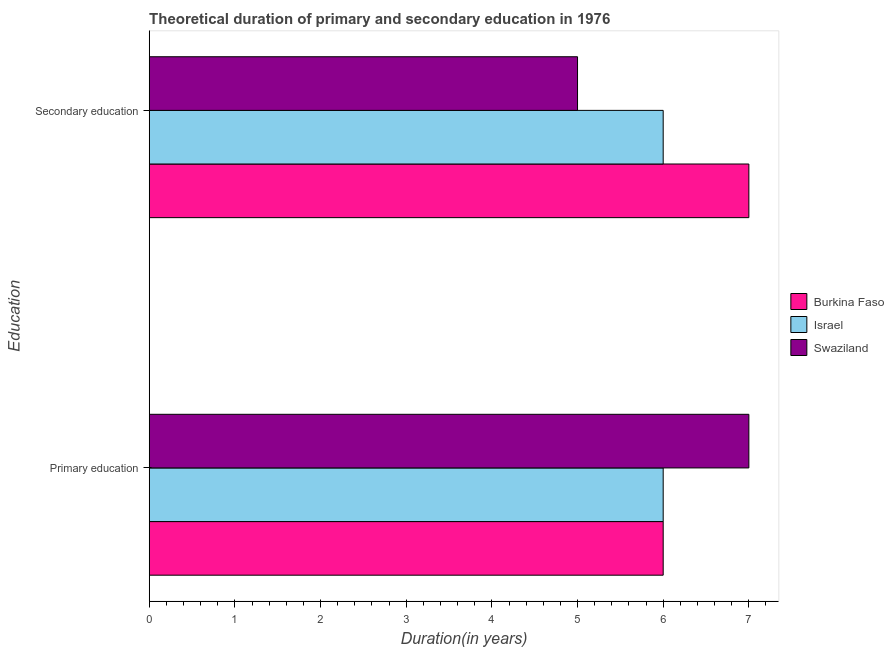How many different coloured bars are there?
Ensure brevity in your answer.  3. Are the number of bars per tick equal to the number of legend labels?
Offer a very short reply. Yes. How many bars are there on the 1st tick from the top?
Offer a very short reply. 3. How many bars are there on the 1st tick from the bottom?
Offer a terse response. 3. What is the label of the 1st group of bars from the top?
Your answer should be compact. Secondary education. What is the duration of secondary education in Swaziland?
Offer a very short reply. 5. Across all countries, what is the maximum duration of primary education?
Your answer should be very brief. 7. In which country was the duration of secondary education maximum?
Your response must be concise. Burkina Faso. In which country was the duration of secondary education minimum?
Offer a terse response. Swaziland. What is the total duration of primary education in the graph?
Offer a very short reply. 19. What is the difference between the duration of secondary education in Israel and that in Swaziland?
Your answer should be very brief. 1. What is the difference between the duration of primary education in Burkina Faso and the duration of secondary education in Swaziland?
Your answer should be compact. 1. What is the average duration of primary education per country?
Make the answer very short. 6.33. What is the difference between the duration of secondary education and duration of primary education in Israel?
Your response must be concise. 0. In how many countries, is the duration of secondary education greater than 1.8 years?
Your response must be concise. 3. What is the ratio of the duration of primary education in Burkina Faso to that in Israel?
Your response must be concise. 1. In how many countries, is the duration of secondary education greater than the average duration of secondary education taken over all countries?
Your answer should be very brief. 1. What does the 3rd bar from the top in Primary education represents?
Your answer should be very brief. Burkina Faso. What does the 1st bar from the bottom in Primary education represents?
Make the answer very short. Burkina Faso. How many bars are there?
Your response must be concise. 6. Are the values on the major ticks of X-axis written in scientific E-notation?
Your answer should be compact. No. Does the graph contain any zero values?
Ensure brevity in your answer.  No. Where does the legend appear in the graph?
Ensure brevity in your answer.  Center right. How many legend labels are there?
Keep it short and to the point. 3. What is the title of the graph?
Ensure brevity in your answer.  Theoretical duration of primary and secondary education in 1976. What is the label or title of the X-axis?
Provide a succinct answer. Duration(in years). What is the label or title of the Y-axis?
Provide a succinct answer. Education. What is the Duration(in years) of Burkina Faso in Primary education?
Ensure brevity in your answer.  6. What is the Duration(in years) of Israel in Primary education?
Your response must be concise. 6. Across all Education, what is the maximum Duration(in years) of Israel?
Offer a very short reply. 6. Across all Education, what is the maximum Duration(in years) in Swaziland?
Offer a very short reply. 7. Across all Education, what is the minimum Duration(in years) of Israel?
Offer a very short reply. 6. Across all Education, what is the minimum Duration(in years) in Swaziland?
Your response must be concise. 5. What is the total Duration(in years) of Burkina Faso in the graph?
Provide a succinct answer. 13. What is the total Duration(in years) in Israel in the graph?
Provide a short and direct response. 12. What is the total Duration(in years) of Swaziland in the graph?
Keep it short and to the point. 12. What is the difference between the Duration(in years) of Burkina Faso in Primary education and that in Secondary education?
Your response must be concise. -1. What is the difference between the Duration(in years) in Israel in Primary education and that in Secondary education?
Your answer should be compact. 0. What is the difference between the Duration(in years) in Swaziland in Primary education and that in Secondary education?
Your response must be concise. 2. What is the difference between the Duration(in years) of Burkina Faso in Primary education and the Duration(in years) of Swaziland in Secondary education?
Your answer should be very brief. 1. What is the difference between the Duration(in years) in Israel and Duration(in years) in Swaziland in Primary education?
Ensure brevity in your answer.  -1. What is the difference between the Duration(in years) in Burkina Faso and Duration(in years) in Israel in Secondary education?
Your response must be concise. 1. What is the ratio of the Duration(in years) of Israel in Primary education to that in Secondary education?
Provide a short and direct response. 1. What is the ratio of the Duration(in years) in Swaziland in Primary education to that in Secondary education?
Your answer should be compact. 1.4. What is the difference between the highest and the second highest Duration(in years) of Israel?
Provide a succinct answer. 0. What is the difference between the highest and the second highest Duration(in years) of Swaziland?
Keep it short and to the point. 2. What is the difference between the highest and the lowest Duration(in years) in Burkina Faso?
Provide a short and direct response. 1. What is the difference between the highest and the lowest Duration(in years) of Israel?
Make the answer very short. 0. 